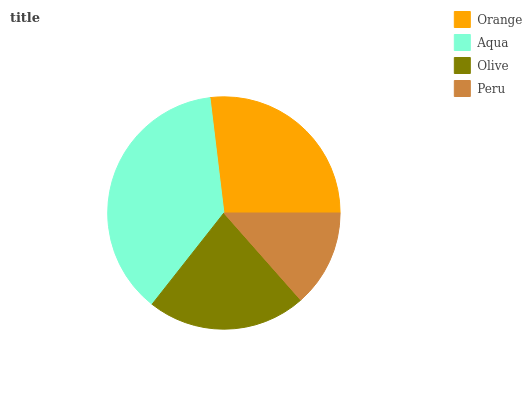Is Peru the minimum?
Answer yes or no. Yes. Is Aqua the maximum?
Answer yes or no. Yes. Is Olive the minimum?
Answer yes or no. No. Is Olive the maximum?
Answer yes or no. No. Is Aqua greater than Olive?
Answer yes or no. Yes. Is Olive less than Aqua?
Answer yes or no. Yes. Is Olive greater than Aqua?
Answer yes or no. No. Is Aqua less than Olive?
Answer yes or no. No. Is Orange the high median?
Answer yes or no. Yes. Is Olive the low median?
Answer yes or no. Yes. Is Olive the high median?
Answer yes or no. No. Is Aqua the low median?
Answer yes or no. No. 